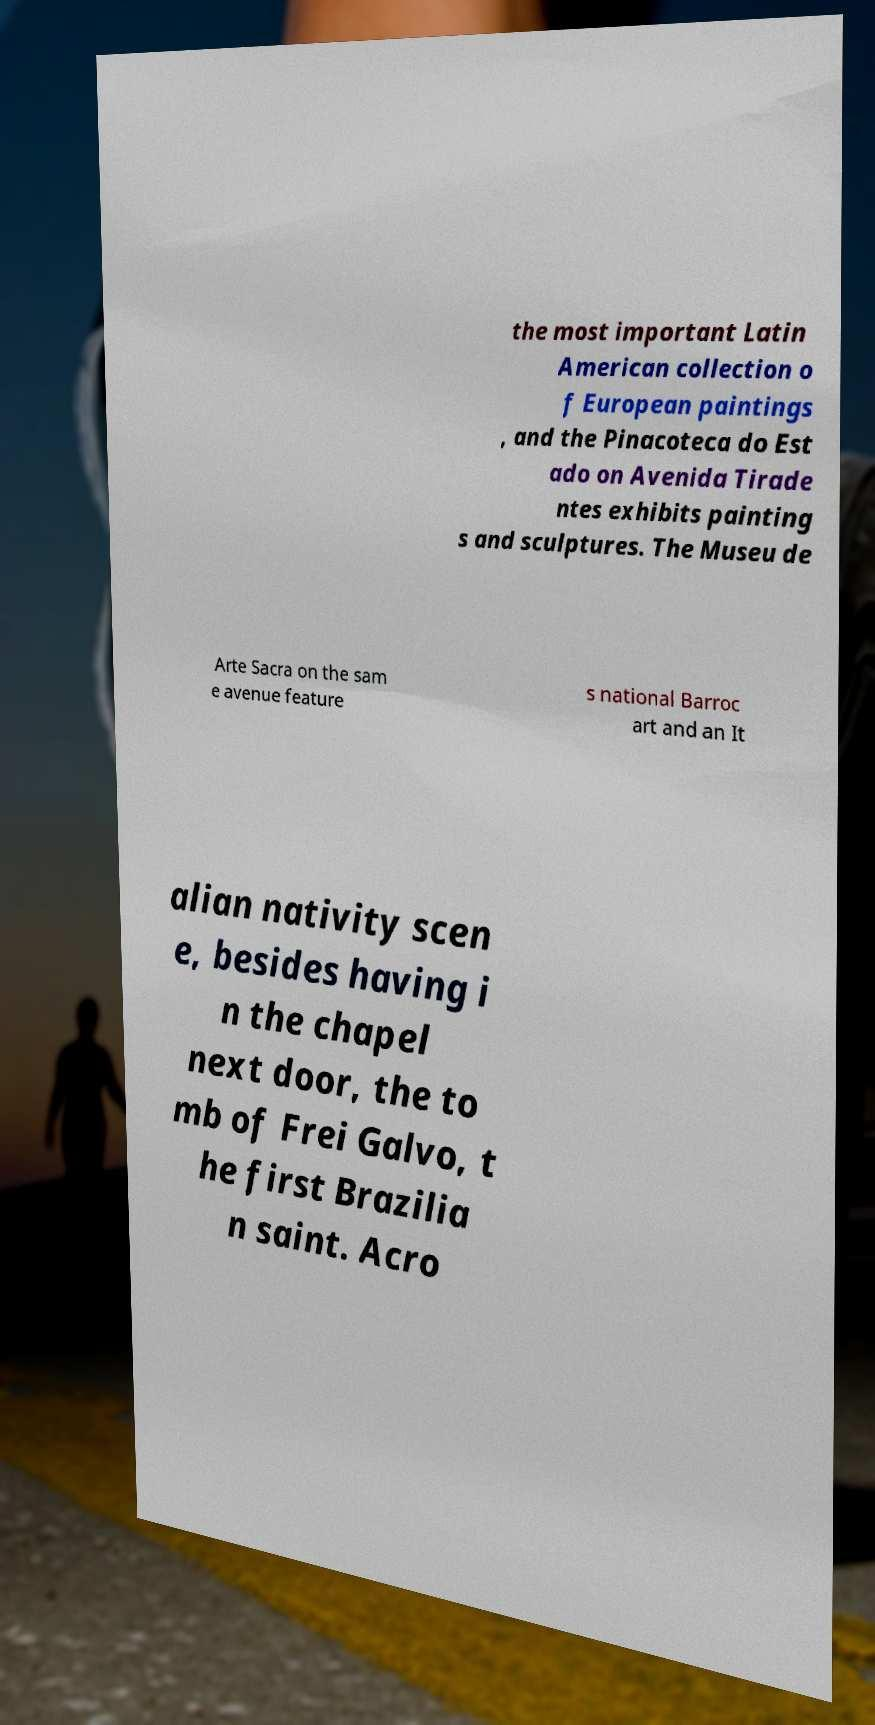Can you accurately transcribe the text from the provided image for me? the most important Latin American collection o f European paintings , and the Pinacoteca do Est ado on Avenida Tirade ntes exhibits painting s and sculptures. The Museu de Arte Sacra on the sam e avenue feature s national Barroc art and an It alian nativity scen e, besides having i n the chapel next door, the to mb of Frei Galvo, t he first Brazilia n saint. Acro 